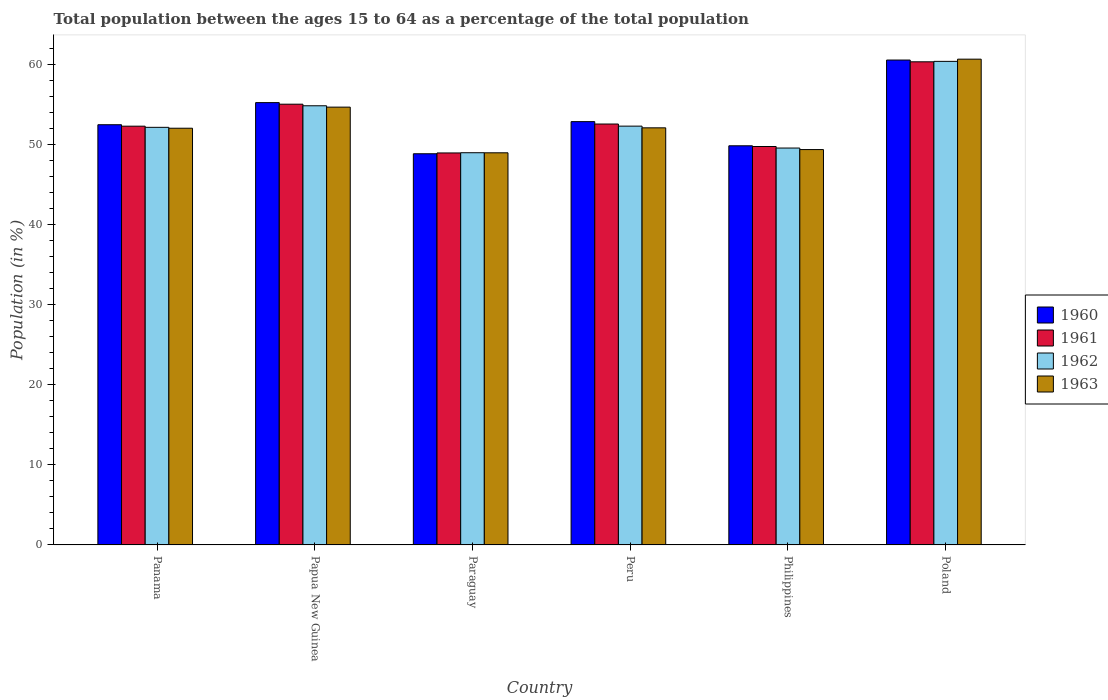How many groups of bars are there?
Provide a succinct answer. 6. Are the number of bars on each tick of the X-axis equal?
Your response must be concise. Yes. How many bars are there on the 6th tick from the right?
Offer a very short reply. 4. What is the label of the 1st group of bars from the left?
Keep it short and to the point. Panama. In how many cases, is the number of bars for a given country not equal to the number of legend labels?
Provide a short and direct response. 0. What is the percentage of the population ages 15 to 64 in 1960 in Poland?
Provide a short and direct response. 60.61. Across all countries, what is the maximum percentage of the population ages 15 to 64 in 1960?
Your response must be concise. 60.61. Across all countries, what is the minimum percentage of the population ages 15 to 64 in 1962?
Your answer should be compact. 49.02. In which country was the percentage of the population ages 15 to 64 in 1962 maximum?
Ensure brevity in your answer.  Poland. In which country was the percentage of the population ages 15 to 64 in 1960 minimum?
Your answer should be compact. Paraguay. What is the total percentage of the population ages 15 to 64 in 1962 in the graph?
Give a very brief answer. 318.51. What is the difference between the percentage of the population ages 15 to 64 in 1963 in Panama and that in Peru?
Offer a terse response. -0.05. What is the difference between the percentage of the population ages 15 to 64 in 1962 in Panama and the percentage of the population ages 15 to 64 in 1960 in Papua New Guinea?
Ensure brevity in your answer.  -3.09. What is the average percentage of the population ages 15 to 64 in 1962 per country?
Keep it short and to the point. 53.09. What is the difference between the percentage of the population ages 15 to 64 of/in 1960 and percentage of the population ages 15 to 64 of/in 1963 in Papua New Guinea?
Give a very brief answer. 0.57. What is the ratio of the percentage of the population ages 15 to 64 in 1961 in Panama to that in Paraguay?
Keep it short and to the point. 1.07. Is the percentage of the population ages 15 to 64 in 1960 in Papua New Guinea less than that in Peru?
Ensure brevity in your answer.  No. What is the difference between the highest and the second highest percentage of the population ages 15 to 64 in 1960?
Provide a short and direct response. 7.7. What is the difference between the highest and the lowest percentage of the population ages 15 to 64 in 1960?
Your answer should be very brief. 11.71. In how many countries, is the percentage of the population ages 15 to 64 in 1961 greater than the average percentage of the population ages 15 to 64 in 1961 taken over all countries?
Your response must be concise. 2. Is it the case that in every country, the sum of the percentage of the population ages 15 to 64 in 1961 and percentage of the population ages 15 to 64 in 1963 is greater than the sum of percentage of the population ages 15 to 64 in 1962 and percentage of the population ages 15 to 64 in 1960?
Make the answer very short. No. What does the 4th bar from the right in Poland represents?
Offer a very short reply. 1960. How many countries are there in the graph?
Offer a very short reply. 6. Does the graph contain any zero values?
Your response must be concise. No. Does the graph contain grids?
Your answer should be very brief. No. What is the title of the graph?
Your answer should be very brief. Total population between the ages 15 to 64 as a percentage of the total population. What is the label or title of the X-axis?
Offer a terse response. Country. What is the Population (in %) of 1960 in Panama?
Offer a very short reply. 52.52. What is the Population (in %) of 1961 in Panama?
Offer a very short reply. 52.34. What is the Population (in %) of 1962 in Panama?
Give a very brief answer. 52.2. What is the Population (in %) of 1963 in Panama?
Your answer should be very brief. 52.09. What is the Population (in %) in 1960 in Papua New Guinea?
Your answer should be compact. 55.29. What is the Population (in %) in 1961 in Papua New Guinea?
Provide a short and direct response. 55.09. What is the Population (in %) of 1962 in Papua New Guinea?
Your answer should be compact. 54.89. What is the Population (in %) of 1963 in Papua New Guinea?
Ensure brevity in your answer.  54.72. What is the Population (in %) of 1960 in Paraguay?
Offer a very short reply. 48.9. What is the Population (in %) of 1961 in Paraguay?
Make the answer very short. 49. What is the Population (in %) of 1962 in Paraguay?
Your response must be concise. 49.02. What is the Population (in %) of 1963 in Paraguay?
Ensure brevity in your answer.  49.01. What is the Population (in %) in 1960 in Peru?
Ensure brevity in your answer.  52.91. What is the Population (in %) of 1961 in Peru?
Offer a very short reply. 52.61. What is the Population (in %) of 1962 in Peru?
Provide a short and direct response. 52.35. What is the Population (in %) in 1963 in Peru?
Give a very brief answer. 52.13. What is the Population (in %) in 1960 in Philippines?
Your response must be concise. 49.89. What is the Population (in %) in 1961 in Philippines?
Make the answer very short. 49.8. What is the Population (in %) of 1962 in Philippines?
Keep it short and to the point. 49.61. What is the Population (in %) in 1963 in Philippines?
Offer a terse response. 49.42. What is the Population (in %) in 1960 in Poland?
Your response must be concise. 60.61. What is the Population (in %) of 1961 in Poland?
Give a very brief answer. 60.39. What is the Population (in %) of 1962 in Poland?
Your response must be concise. 60.44. What is the Population (in %) in 1963 in Poland?
Ensure brevity in your answer.  60.72. Across all countries, what is the maximum Population (in %) in 1960?
Give a very brief answer. 60.61. Across all countries, what is the maximum Population (in %) in 1961?
Give a very brief answer. 60.39. Across all countries, what is the maximum Population (in %) of 1962?
Your answer should be compact. 60.44. Across all countries, what is the maximum Population (in %) in 1963?
Your response must be concise. 60.72. Across all countries, what is the minimum Population (in %) in 1960?
Offer a terse response. 48.9. Across all countries, what is the minimum Population (in %) of 1961?
Your response must be concise. 49. Across all countries, what is the minimum Population (in %) of 1962?
Give a very brief answer. 49.02. Across all countries, what is the minimum Population (in %) in 1963?
Make the answer very short. 49.01. What is the total Population (in %) in 1960 in the graph?
Give a very brief answer. 320.12. What is the total Population (in %) in 1961 in the graph?
Keep it short and to the point. 319.23. What is the total Population (in %) of 1962 in the graph?
Keep it short and to the point. 318.51. What is the total Population (in %) of 1963 in the graph?
Provide a short and direct response. 318.09. What is the difference between the Population (in %) in 1960 in Panama and that in Papua New Guinea?
Provide a succinct answer. -2.76. What is the difference between the Population (in %) in 1961 in Panama and that in Papua New Guinea?
Offer a terse response. -2.75. What is the difference between the Population (in %) in 1962 in Panama and that in Papua New Guinea?
Provide a succinct answer. -2.7. What is the difference between the Population (in %) of 1963 in Panama and that in Papua New Guinea?
Your answer should be very brief. -2.64. What is the difference between the Population (in %) in 1960 in Panama and that in Paraguay?
Provide a succinct answer. 3.63. What is the difference between the Population (in %) in 1961 in Panama and that in Paraguay?
Your response must be concise. 3.35. What is the difference between the Population (in %) in 1962 in Panama and that in Paraguay?
Your answer should be compact. 3.17. What is the difference between the Population (in %) in 1963 in Panama and that in Paraguay?
Offer a terse response. 3.07. What is the difference between the Population (in %) of 1960 in Panama and that in Peru?
Provide a short and direct response. -0.39. What is the difference between the Population (in %) of 1961 in Panama and that in Peru?
Make the answer very short. -0.27. What is the difference between the Population (in %) of 1962 in Panama and that in Peru?
Provide a short and direct response. -0.15. What is the difference between the Population (in %) in 1963 in Panama and that in Peru?
Your answer should be compact. -0.05. What is the difference between the Population (in %) in 1960 in Panama and that in Philippines?
Ensure brevity in your answer.  2.63. What is the difference between the Population (in %) in 1961 in Panama and that in Philippines?
Your answer should be very brief. 2.54. What is the difference between the Population (in %) in 1962 in Panama and that in Philippines?
Give a very brief answer. 2.59. What is the difference between the Population (in %) in 1963 in Panama and that in Philippines?
Make the answer very short. 2.67. What is the difference between the Population (in %) in 1960 in Panama and that in Poland?
Offer a terse response. -8.09. What is the difference between the Population (in %) in 1961 in Panama and that in Poland?
Ensure brevity in your answer.  -8.05. What is the difference between the Population (in %) of 1962 in Panama and that in Poland?
Offer a very short reply. -8.25. What is the difference between the Population (in %) in 1963 in Panama and that in Poland?
Provide a short and direct response. -8.63. What is the difference between the Population (in %) in 1960 in Papua New Guinea and that in Paraguay?
Give a very brief answer. 6.39. What is the difference between the Population (in %) in 1961 in Papua New Guinea and that in Paraguay?
Make the answer very short. 6.09. What is the difference between the Population (in %) in 1962 in Papua New Guinea and that in Paraguay?
Your response must be concise. 5.87. What is the difference between the Population (in %) in 1963 in Papua New Guinea and that in Paraguay?
Offer a terse response. 5.71. What is the difference between the Population (in %) in 1960 in Papua New Guinea and that in Peru?
Provide a succinct answer. 2.38. What is the difference between the Population (in %) in 1961 in Papua New Guinea and that in Peru?
Give a very brief answer. 2.48. What is the difference between the Population (in %) of 1962 in Papua New Guinea and that in Peru?
Provide a succinct answer. 2.55. What is the difference between the Population (in %) in 1963 in Papua New Guinea and that in Peru?
Offer a terse response. 2.59. What is the difference between the Population (in %) in 1960 in Papua New Guinea and that in Philippines?
Your response must be concise. 5.4. What is the difference between the Population (in %) of 1961 in Papua New Guinea and that in Philippines?
Ensure brevity in your answer.  5.29. What is the difference between the Population (in %) in 1962 in Papua New Guinea and that in Philippines?
Ensure brevity in your answer.  5.28. What is the difference between the Population (in %) in 1963 in Papua New Guinea and that in Philippines?
Your answer should be compact. 5.3. What is the difference between the Population (in %) of 1960 in Papua New Guinea and that in Poland?
Your response must be concise. -5.32. What is the difference between the Population (in %) of 1961 in Papua New Guinea and that in Poland?
Ensure brevity in your answer.  -5.3. What is the difference between the Population (in %) in 1962 in Papua New Guinea and that in Poland?
Ensure brevity in your answer.  -5.55. What is the difference between the Population (in %) in 1963 in Papua New Guinea and that in Poland?
Offer a very short reply. -6. What is the difference between the Population (in %) of 1960 in Paraguay and that in Peru?
Provide a succinct answer. -4.02. What is the difference between the Population (in %) in 1961 in Paraguay and that in Peru?
Keep it short and to the point. -3.62. What is the difference between the Population (in %) in 1962 in Paraguay and that in Peru?
Provide a succinct answer. -3.32. What is the difference between the Population (in %) of 1963 in Paraguay and that in Peru?
Provide a short and direct response. -3.12. What is the difference between the Population (in %) of 1960 in Paraguay and that in Philippines?
Your answer should be very brief. -0.99. What is the difference between the Population (in %) in 1961 in Paraguay and that in Philippines?
Offer a very short reply. -0.81. What is the difference between the Population (in %) in 1962 in Paraguay and that in Philippines?
Keep it short and to the point. -0.59. What is the difference between the Population (in %) in 1963 in Paraguay and that in Philippines?
Make the answer very short. -0.4. What is the difference between the Population (in %) in 1960 in Paraguay and that in Poland?
Ensure brevity in your answer.  -11.71. What is the difference between the Population (in %) in 1961 in Paraguay and that in Poland?
Offer a very short reply. -11.39. What is the difference between the Population (in %) of 1962 in Paraguay and that in Poland?
Offer a very short reply. -11.42. What is the difference between the Population (in %) of 1963 in Paraguay and that in Poland?
Provide a short and direct response. -11.7. What is the difference between the Population (in %) in 1960 in Peru and that in Philippines?
Your response must be concise. 3.02. What is the difference between the Population (in %) in 1961 in Peru and that in Philippines?
Ensure brevity in your answer.  2.81. What is the difference between the Population (in %) in 1962 in Peru and that in Philippines?
Your response must be concise. 2.74. What is the difference between the Population (in %) in 1963 in Peru and that in Philippines?
Your answer should be very brief. 2.72. What is the difference between the Population (in %) in 1960 in Peru and that in Poland?
Make the answer very short. -7.7. What is the difference between the Population (in %) in 1961 in Peru and that in Poland?
Make the answer very short. -7.78. What is the difference between the Population (in %) of 1962 in Peru and that in Poland?
Your answer should be very brief. -8.1. What is the difference between the Population (in %) of 1963 in Peru and that in Poland?
Offer a terse response. -8.58. What is the difference between the Population (in %) in 1960 in Philippines and that in Poland?
Provide a short and direct response. -10.72. What is the difference between the Population (in %) in 1961 in Philippines and that in Poland?
Your answer should be very brief. -10.59. What is the difference between the Population (in %) of 1962 in Philippines and that in Poland?
Offer a very short reply. -10.83. What is the difference between the Population (in %) in 1963 in Philippines and that in Poland?
Make the answer very short. -11.3. What is the difference between the Population (in %) in 1960 in Panama and the Population (in %) in 1961 in Papua New Guinea?
Your answer should be compact. -2.57. What is the difference between the Population (in %) in 1960 in Panama and the Population (in %) in 1962 in Papua New Guinea?
Keep it short and to the point. -2.37. What is the difference between the Population (in %) in 1960 in Panama and the Population (in %) in 1963 in Papua New Guinea?
Make the answer very short. -2.2. What is the difference between the Population (in %) in 1961 in Panama and the Population (in %) in 1962 in Papua New Guinea?
Your answer should be very brief. -2.55. What is the difference between the Population (in %) of 1961 in Panama and the Population (in %) of 1963 in Papua New Guinea?
Your answer should be very brief. -2.38. What is the difference between the Population (in %) in 1962 in Panama and the Population (in %) in 1963 in Papua New Guinea?
Keep it short and to the point. -2.52. What is the difference between the Population (in %) in 1960 in Panama and the Population (in %) in 1961 in Paraguay?
Provide a short and direct response. 3.53. What is the difference between the Population (in %) of 1960 in Panama and the Population (in %) of 1962 in Paraguay?
Offer a terse response. 3.5. What is the difference between the Population (in %) in 1960 in Panama and the Population (in %) in 1963 in Paraguay?
Your answer should be compact. 3.51. What is the difference between the Population (in %) of 1961 in Panama and the Population (in %) of 1962 in Paraguay?
Provide a succinct answer. 3.32. What is the difference between the Population (in %) of 1961 in Panama and the Population (in %) of 1963 in Paraguay?
Offer a terse response. 3.33. What is the difference between the Population (in %) of 1962 in Panama and the Population (in %) of 1963 in Paraguay?
Provide a succinct answer. 3.18. What is the difference between the Population (in %) of 1960 in Panama and the Population (in %) of 1961 in Peru?
Your answer should be very brief. -0.09. What is the difference between the Population (in %) of 1960 in Panama and the Population (in %) of 1962 in Peru?
Provide a succinct answer. 0.18. What is the difference between the Population (in %) in 1960 in Panama and the Population (in %) in 1963 in Peru?
Keep it short and to the point. 0.39. What is the difference between the Population (in %) of 1961 in Panama and the Population (in %) of 1962 in Peru?
Your response must be concise. -0.01. What is the difference between the Population (in %) of 1961 in Panama and the Population (in %) of 1963 in Peru?
Offer a terse response. 0.21. What is the difference between the Population (in %) of 1962 in Panama and the Population (in %) of 1963 in Peru?
Keep it short and to the point. 0.06. What is the difference between the Population (in %) of 1960 in Panama and the Population (in %) of 1961 in Philippines?
Your answer should be very brief. 2.72. What is the difference between the Population (in %) in 1960 in Panama and the Population (in %) in 1962 in Philippines?
Your answer should be very brief. 2.91. What is the difference between the Population (in %) in 1960 in Panama and the Population (in %) in 1963 in Philippines?
Your response must be concise. 3.11. What is the difference between the Population (in %) of 1961 in Panama and the Population (in %) of 1962 in Philippines?
Keep it short and to the point. 2.73. What is the difference between the Population (in %) of 1961 in Panama and the Population (in %) of 1963 in Philippines?
Make the answer very short. 2.92. What is the difference between the Population (in %) in 1962 in Panama and the Population (in %) in 1963 in Philippines?
Your response must be concise. 2.78. What is the difference between the Population (in %) of 1960 in Panama and the Population (in %) of 1961 in Poland?
Your answer should be very brief. -7.86. What is the difference between the Population (in %) in 1960 in Panama and the Population (in %) in 1962 in Poland?
Provide a succinct answer. -7.92. What is the difference between the Population (in %) of 1960 in Panama and the Population (in %) of 1963 in Poland?
Offer a very short reply. -8.19. What is the difference between the Population (in %) in 1961 in Panama and the Population (in %) in 1962 in Poland?
Give a very brief answer. -8.1. What is the difference between the Population (in %) of 1961 in Panama and the Population (in %) of 1963 in Poland?
Your answer should be compact. -8.38. What is the difference between the Population (in %) of 1962 in Panama and the Population (in %) of 1963 in Poland?
Your answer should be compact. -8.52. What is the difference between the Population (in %) of 1960 in Papua New Guinea and the Population (in %) of 1961 in Paraguay?
Provide a short and direct response. 6.29. What is the difference between the Population (in %) of 1960 in Papua New Guinea and the Population (in %) of 1962 in Paraguay?
Keep it short and to the point. 6.27. What is the difference between the Population (in %) in 1960 in Papua New Guinea and the Population (in %) in 1963 in Paraguay?
Your answer should be very brief. 6.27. What is the difference between the Population (in %) in 1961 in Papua New Guinea and the Population (in %) in 1962 in Paraguay?
Provide a short and direct response. 6.07. What is the difference between the Population (in %) in 1961 in Papua New Guinea and the Population (in %) in 1963 in Paraguay?
Make the answer very short. 6.08. What is the difference between the Population (in %) in 1962 in Papua New Guinea and the Population (in %) in 1963 in Paraguay?
Ensure brevity in your answer.  5.88. What is the difference between the Population (in %) of 1960 in Papua New Guinea and the Population (in %) of 1961 in Peru?
Offer a terse response. 2.68. What is the difference between the Population (in %) in 1960 in Papua New Guinea and the Population (in %) in 1962 in Peru?
Offer a very short reply. 2.94. What is the difference between the Population (in %) in 1960 in Papua New Guinea and the Population (in %) in 1963 in Peru?
Give a very brief answer. 3.15. What is the difference between the Population (in %) of 1961 in Papua New Guinea and the Population (in %) of 1962 in Peru?
Keep it short and to the point. 2.74. What is the difference between the Population (in %) of 1961 in Papua New Guinea and the Population (in %) of 1963 in Peru?
Your answer should be very brief. 2.96. What is the difference between the Population (in %) of 1962 in Papua New Guinea and the Population (in %) of 1963 in Peru?
Your answer should be compact. 2.76. What is the difference between the Population (in %) in 1960 in Papua New Guinea and the Population (in %) in 1961 in Philippines?
Make the answer very short. 5.49. What is the difference between the Population (in %) in 1960 in Papua New Guinea and the Population (in %) in 1962 in Philippines?
Provide a succinct answer. 5.68. What is the difference between the Population (in %) in 1960 in Papua New Guinea and the Population (in %) in 1963 in Philippines?
Ensure brevity in your answer.  5.87. What is the difference between the Population (in %) of 1961 in Papua New Guinea and the Population (in %) of 1962 in Philippines?
Provide a succinct answer. 5.48. What is the difference between the Population (in %) of 1961 in Papua New Guinea and the Population (in %) of 1963 in Philippines?
Provide a succinct answer. 5.67. What is the difference between the Population (in %) in 1962 in Papua New Guinea and the Population (in %) in 1963 in Philippines?
Your answer should be very brief. 5.47. What is the difference between the Population (in %) of 1960 in Papua New Guinea and the Population (in %) of 1961 in Poland?
Offer a very short reply. -5.1. What is the difference between the Population (in %) in 1960 in Papua New Guinea and the Population (in %) in 1962 in Poland?
Your answer should be very brief. -5.16. What is the difference between the Population (in %) in 1960 in Papua New Guinea and the Population (in %) in 1963 in Poland?
Provide a short and direct response. -5.43. What is the difference between the Population (in %) in 1961 in Papua New Guinea and the Population (in %) in 1962 in Poland?
Offer a very short reply. -5.35. What is the difference between the Population (in %) of 1961 in Papua New Guinea and the Population (in %) of 1963 in Poland?
Offer a terse response. -5.63. What is the difference between the Population (in %) of 1962 in Papua New Guinea and the Population (in %) of 1963 in Poland?
Give a very brief answer. -5.83. What is the difference between the Population (in %) in 1960 in Paraguay and the Population (in %) in 1961 in Peru?
Provide a short and direct response. -3.72. What is the difference between the Population (in %) in 1960 in Paraguay and the Population (in %) in 1962 in Peru?
Provide a succinct answer. -3.45. What is the difference between the Population (in %) in 1960 in Paraguay and the Population (in %) in 1963 in Peru?
Your answer should be very brief. -3.24. What is the difference between the Population (in %) in 1961 in Paraguay and the Population (in %) in 1962 in Peru?
Offer a very short reply. -3.35. What is the difference between the Population (in %) in 1961 in Paraguay and the Population (in %) in 1963 in Peru?
Your answer should be very brief. -3.14. What is the difference between the Population (in %) of 1962 in Paraguay and the Population (in %) of 1963 in Peru?
Offer a very short reply. -3.11. What is the difference between the Population (in %) in 1960 in Paraguay and the Population (in %) in 1961 in Philippines?
Make the answer very short. -0.91. What is the difference between the Population (in %) of 1960 in Paraguay and the Population (in %) of 1962 in Philippines?
Offer a very short reply. -0.71. What is the difference between the Population (in %) of 1960 in Paraguay and the Population (in %) of 1963 in Philippines?
Offer a very short reply. -0.52. What is the difference between the Population (in %) in 1961 in Paraguay and the Population (in %) in 1962 in Philippines?
Your answer should be very brief. -0.61. What is the difference between the Population (in %) of 1961 in Paraguay and the Population (in %) of 1963 in Philippines?
Provide a succinct answer. -0.42. What is the difference between the Population (in %) of 1962 in Paraguay and the Population (in %) of 1963 in Philippines?
Give a very brief answer. -0.4. What is the difference between the Population (in %) of 1960 in Paraguay and the Population (in %) of 1961 in Poland?
Offer a very short reply. -11.49. What is the difference between the Population (in %) in 1960 in Paraguay and the Population (in %) in 1962 in Poland?
Offer a terse response. -11.55. What is the difference between the Population (in %) in 1960 in Paraguay and the Population (in %) in 1963 in Poland?
Your answer should be compact. -11.82. What is the difference between the Population (in %) of 1961 in Paraguay and the Population (in %) of 1962 in Poland?
Keep it short and to the point. -11.45. What is the difference between the Population (in %) of 1961 in Paraguay and the Population (in %) of 1963 in Poland?
Offer a terse response. -11.72. What is the difference between the Population (in %) in 1962 in Paraguay and the Population (in %) in 1963 in Poland?
Offer a very short reply. -11.7. What is the difference between the Population (in %) in 1960 in Peru and the Population (in %) in 1961 in Philippines?
Ensure brevity in your answer.  3.11. What is the difference between the Population (in %) of 1960 in Peru and the Population (in %) of 1962 in Philippines?
Make the answer very short. 3.3. What is the difference between the Population (in %) in 1960 in Peru and the Population (in %) in 1963 in Philippines?
Your answer should be compact. 3.49. What is the difference between the Population (in %) of 1961 in Peru and the Population (in %) of 1962 in Philippines?
Ensure brevity in your answer.  3. What is the difference between the Population (in %) of 1961 in Peru and the Population (in %) of 1963 in Philippines?
Offer a very short reply. 3.19. What is the difference between the Population (in %) in 1962 in Peru and the Population (in %) in 1963 in Philippines?
Make the answer very short. 2.93. What is the difference between the Population (in %) in 1960 in Peru and the Population (in %) in 1961 in Poland?
Make the answer very short. -7.48. What is the difference between the Population (in %) in 1960 in Peru and the Population (in %) in 1962 in Poland?
Your response must be concise. -7.53. What is the difference between the Population (in %) of 1960 in Peru and the Population (in %) of 1963 in Poland?
Give a very brief answer. -7.81. What is the difference between the Population (in %) in 1961 in Peru and the Population (in %) in 1962 in Poland?
Your answer should be compact. -7.83. What is the difference between the Population (in %) in 1961 in Peru and the Population (in %) in 1963 in Poland?
Offer a very short reply. -8.11. What is the difference between the Population (in %) in 1962 in Peru and the Population (in %) in 1963 in Poland?
Keep it short and to the point. -8.37. What is the difference between the Population (in %) in 1960 in Philippines and the Population (in %) in 1961 in Poland?
Offer a very short reply. -10.5. What is the difference between the Population (in %) of 1960 in Philippines and the Population (in %) of 1962 in Poland?
Offer a terse response. -10.55. What is the difference between the Population (in %) of 1960 in Philippines and the Population (in %) of 1963 in Poland?
Give a very brief answer. -10.83. What is the difference between the Population (in %) of 1961 in Philippines and the Population (in %) of 1962 in Poland?
Give a very brief answer. -10.64. What is the difference between the Population (in %) in 1961 in Philippines and the Population (in %) in 1963 in Poland?
Offer a terse response. -10.92. What is the difference between the Population (in %) of 1962 in Philippines and the Population (in %) of 1963 in Poland?
Give a very brief answer. -11.11. What is the average Population (in %) of 1960 per country?
Make the answer very short. 53.35. What is the average Population (in %) in 1961 per country?
Offer a terse response. 53.2. What is the average Population (in %) in 1962 per country?
Your answer should be very brief. 53.09. What is the average Population (in %) of 1963 per country?
Your answer should be very brief. 53.02. What is the difference between the Population (in %) in 1960 and Population (in %) in 1961 in Panama?
Keep it short and to the point. 0.18. What is the difference between the Population (in %) of 1960 and Population (in %) of 1962 in Panama?
Keep it short and to the point. 0.33. What is the difference between the Population (in %) of 1960 and Population (in %) of 1963 in Panama?
Provide a succinct answer. 0.44. What is the difference between the Population (in %) in 1961 and Population (in %) in 1962 in Panama?
Offer a very short reply. 0.15. What is the difference between the Population (in %) of 1961 and Population (in %) of 1963 in Panama?
Offer a very short reply. 0.26. What is the difference between the Population (in %) in 1962 and Population (in %) in 1963 in Panama?
Give a very brief answer. 0.11. What is the difference between the Population (in %) in 1960 and Population (in %) in 1961 in Papua New Guinea?
Keep it short and to the point. 0.2. What is the difference between the Population (in %) in 1960 and Population (in %) in 1962 in Papua New Guinea?
Your answer should be compact. 0.4. What is the difference between the Population (in %) of 1960 and Population (in %) of 1963 in Papua New Guinea?
Your answer should be very brief. 0.57. What is the difference between the Population (in %) in 1961 and Population (in %) in 1962 in Papua New Guinea?
Your answer should be compact. 0.2. What is the difference between the Population (in %) in 1961 and Population (in %) in 1963 in Papua New Guinea?
Keep it short and to the point. 0.37. What is the difference between the Population (in %) in 1962 and Population (in %) in 1963 in Papua New Guinea?
Ensure brevity in your answer.  0.17. What is the difference between the Population (in %) of 1960 and Population (in %) of 1961 in Paraguay?
Provide a succinct answer. -0.1. What is the difference between the Population (in %) of 1960 and Population (in %) of 1962 in Paraguay?
Ensure brevity in your answer.  -0.13. What is the difference between the Population (in %) of 1960 and Population (in %) of 1963 in Paraguay?
Provide a succinct answer. -0.12. What is the difference between the Population (in %) in 1961 and Population (in %) in 1962 in Paraguay?
Your answer should be very brief. -0.03. What is the difference between the Population (in %) of 1961 and Population (in %) of 1963 in Paraguay?
Your response must be concise. -0.02. What is the difference between the Population (in %) in 1962 and Population (in %) in 1963 in Paraguay?
Your answer should be compact. 0.01. What is the difference between the Population (in %) of 1960 and Population (in %) of 1961 in Peru?
Your response must be concise. 0.3. What is the difference between the Population (in %) in 1960 and Population (in %) in 1962 in Peru?
Ensure brevity in your answer.  0.56. What is the difference between the Population (in %) of 1960 and Population (in %) of 1963 in Peru?
Offer a very short reply. 0.78. What is the difference between the Population (in %) in 1961 and Population (in %) in 1962 in Peru?
Offer a very short reply. 0.26. What is the difference between the Population (in %) in 1961 and Population (in %) in 1963 in Peru?
Make the answer very short. 0.48. What is the difference between the Population (in %) of 1962 and Population (in %) of 1963 in Peru?
Give a very brief answer. 0.21. What is the difference between the Population (in %) of 1960 and Population (in %) of 1961 in Philippines?
Make the answer very short. 0.09. What is the difference between the Population (in %) of 1960 and Population (in %) of 1962 in Philippines?
Make the answer very short. 0.28. What is the difference between the Population (in %) in 1960 and Population (in %) in 1963 in Philippines?
Offer a very short reply. 0.47. What is the difference between the Population (in %) in 1961 and Population (in %) in 1962 in Philippines?
Offer a terse response. 0.19. What is the difference between the Population (in %) in 1961 and Population (in %) in 1963 in Philippines?
Give a very brief answer. 0.38. What is the difference between the Population (in %) in 1962 and Population (in %) in 1963 in Philippines?
Keep it short and to the point. 0.19. What is the difference between the Population (in %) of 1960 and Population (in %) of 1961 in Poland?
Your answer should be very brief. 0.22. What is the difference between the Population (in %) of 1960 and Population (in %) of 1962 in Poland?
Provide a succinct answer. 0.17. What is the difference between the Population (in %) of 1960 and Population (in %) of 1963 in Poland?
Offer a terse response. -0.11. What is the difference between the Population (in %) of 1961 and Population (in %) of 1962 in Poland?
Your answer should be very brief. -0.06. What is the difference between the Population (in %) in 1961 and Population (in %) in 1963 in Poland?
Ensure brevity in your answer.  -0.33. What is the difference between the Population (in %) in 1962 and Population (in %) in 1963 in Poland?
Keep it short and to the point. -0.27. What is the ratio of the Population (in %) of 1961 in Panama to that in Papua New Guinea?
Your response must be concise. 0.95. What is the ratio of the Population (in %) of 1962 in Panama to that in Papua New Guinea?
Give a very brief answer. 0.95. What is the ratio of the Population (in %) in 1963 in Panama to that in Papua New Guinea?
Make the answer very short. 0.95. What is the ratio of the Population (in %) of 1960 in Panama to that in Paraguay?
Give a very brief answer. 1.07. What is the ratio of the Population (in %) in 1961 in Panama to that in Paraguay?
Offer a terse response. 1.07. What is the ratio of the Population (in %) of 1962 in Panama to that in Paraguay?
Keep it short and to the point. 1.06. What is the ratio of the Population (in %) of 1963 in Panama to that in Paraguay?
Your answer should be compact. 1.06. What is the ratio of the Population (in %) in 1961 in Panama to that in Peru?
Ensure brevity in your answer.  0.99. What is the ratio of the Population (in %) of 1962 in Panama to that in Peru?
Keep it short and to the point. 1. What is the ratio of the Population (in %) in 1960 in Panama to that in Philippines?
Offer a terse response. 1.05. What is the ratio of the Population (in %) in 1961 in Panama to that in Philippines?
Offer a very short reply. 1.05. What is the ratio of the Population (in %) of 1962 in Panama to that in Philippines?
Provide a short and direct response. 1.05. What is the ratio of the Population (in %) in 1963 in Panama to that in Philippines?
Give a very brief answer. 1.05. What is the ratio of the Population (in %) of 1960 in Panama to that in Poland?
Your answer should be compact. 0.87. What is the ratio of the Population (in %) of 1961 in Panama to that in Poland?
Provide a succinct answer. 0.87. What is the ratio of the Population (in %) in 1962 in Panama to that in Poland?
Keep it short and to the point. 0.86. What is the ratio of the Population (in %) in 1963 in Panama to that in Poland?
Your answer should be compact. 0.86. What is the ratio of the Population (in %) of 1960 in Papua New Guinea to that in Paraguay?
Provide a succinct answer. 1.13. What is the ratio of the Population (in %) of 1961 in Papua New Guinea to that in Paraguay?
Your answer should be very brief. 1.12. What is the ratio of the Population (in %) in 1962 in Papua New Guinea to that in Paraguay?
Provide a short and direct response. 1.12. What is the ratio of the Population (in %) in 1963 in Papua New Guinea to that in Paraguay?
Your answer should be compact. 1.12. What is the ratio of the Population (in %) of 1960 in Papua New Guinea to that in Peru?
Provide a succinct answer. 1.04. What is the ratio of the Population (in %) in 1961 in Papua New Guinea to that in Peru?
Offer a very short reply. 1.05. What is the ratio of the Population (in %) in 1962 in Papua New Guinea to that in Peru?
Provide a short and direct response. 1.05. What is the ratio of the Population (in %) of 1963 in Papua New Guinea to that in Peru?
Keep it short and to the point. 1.05. What is the ratio of the Population (in %) in 1960 in Papua New Guinea to that in Philippines?
Your answer should be compact. 1.11. What is the ratio of the Population (in %) of 1961 in Papua New Guinea to that in Philippines?
Your answer should be compact. 1.11. What is the ratio of the Population (in %) in 1962 in Papua New Guinea to that in Philippines?
Your response must be concise. 1.11. What is the ratio of the Population (in %) of 1963 in Papua New Guinea to that in Philippines?
Keep it short and to the point. 1.11. What is the ratio of the Population (in %) of 1960 in Papua New Guinea to that in Poland?
Provide a short and direct response. 0.91. What is the ratio of the Population (in %) in 1961 in Papua New Guinea to that in Poland?
Offer a very short reply. 0.91. What is the ratio of the Population (in %) of 1962 in Papua New Guinea to that in Poland?
Offer a very short reply. 0.91. What is the ratio of the Population (in %) in 1963 in Papua New Guinea to that in Poland?
Offer a terse response. 0.9. What is the ratio of the Population (in %) in 1960 in Paraguay to that in Peru?
Provide a succinct answer. 0.92. What is the ratio of the Population (in %) of 1961 in Paraguay to that in Peru?
Your response must be concise. 0.93. What is the ratio of the Population (in %) of 1962 in Paraguay to that in Peru?
Ensure brevity in your answer.  0.94. What is the ratio of the Population (in %) in 1963 in Paraguay to that in Peru?
Provide a succinct answer. 0.94. What is the ratio of the Population (in %) of 1960 in Paraguay to that in Philippines?
Give a very brief answer. 0.98. What is the ratio of the Population (in %) in 1961 in Paraguay to that in Philippines?
Offer a very short reply. 0.98. What is the ratio of the Population (in %) of 1963 in Paraguay to that in Philippines?
Offer a terse response. 0.99. What is the ratio of the Population (in %) in 1960 in Paraguay to that in Poland?
Offer a terse response. 0.81. What is the ratio of the Population (in %) of 1961 in Paraguay to that in Poland?
Provide a succinct answer. 0.81. What is the ratio of the Population (in %) of 1962 in Paraguay to that in Poland?
Offer a very short reply. 0.81. What is the ratio of the Population (in %) of 1963 in Paraguay to that in Poland?
Your answer should be very brief. 0.81. What is the ratio of the Population (in %) in 1960 in Peru to that in Philippines?
Provide a short and direct response. 1.06. What is the ratio of the Population (in %) of 1961 in Peru to that in Philippines?
Your response must be concise. 1.06. What is the ratio of the Population (in %) in 1962 in Peru to that in Philippines?
Give a very brief answer. 1.06. What is the ratio of the Population (in %) in 1963 in Peru to that in Philippines?
Make the answer very short. 1.05. What is the ratio of the Population (in %) of 1960 in Peru to that in Poland?
Offer a very short reply. 0.87. What is the ratio of the Population (in %) of 1961 in Peru to that in Poland?
Your answer should be very brief. 0.87. What is the ratio of the Population (in %) in 1962 in Peru to that in Poland?
Make the answer very short. 0.87. What is the ratio of the Population (in %) in 1963 in Peru to that in Poland?
Make the answer very short. 0.86. What is the ratio of the Population (in %) in 1960 in Philippines to that in Poland?
Provide a succinct answer. 0.82. What is the ratio of the Population (in %) in 1961 in Philippines to that in Poland?
Ensure brevity in your answer.  0.82. What is the ratio of the Population (in %) in 1962 in Philippines to that in Poland?
Provide a succinct answer. 0.82. What is the ratio of the Population (in %) of 1963 in Philippines to that in Poland?
Your response must be concise. 0.81. What is the difference between the highest and the second highest Population (in %) in 1960?
Give a very brief answer. 5.32. What is the difference between the highest and the second highest Population (in %) in 1961?
Give a very brief answer. 5.3. What is the difference between the highest and the second highest Population (in %) in 1962?
Your answer should be compact. 5.55. What is the difference between the highest and the second highest Population (in %) in 1963?
Keep it short and to the point. 6. What is the difference between the highest and the lowest Population (in %) of 1960?
Give a very brief answer. 11.71. What is the difference between the highest and the lowest Population (in %) in 1961?
Offer a very short reply. 11.39. What is the difference between the highest and the lowest Population (in %) in 1962?
Your response must be concise. 11.42. What is the difference between the highest and the lowest Population (in %) in 1963?
Keep it short and to the point. 11.7. 